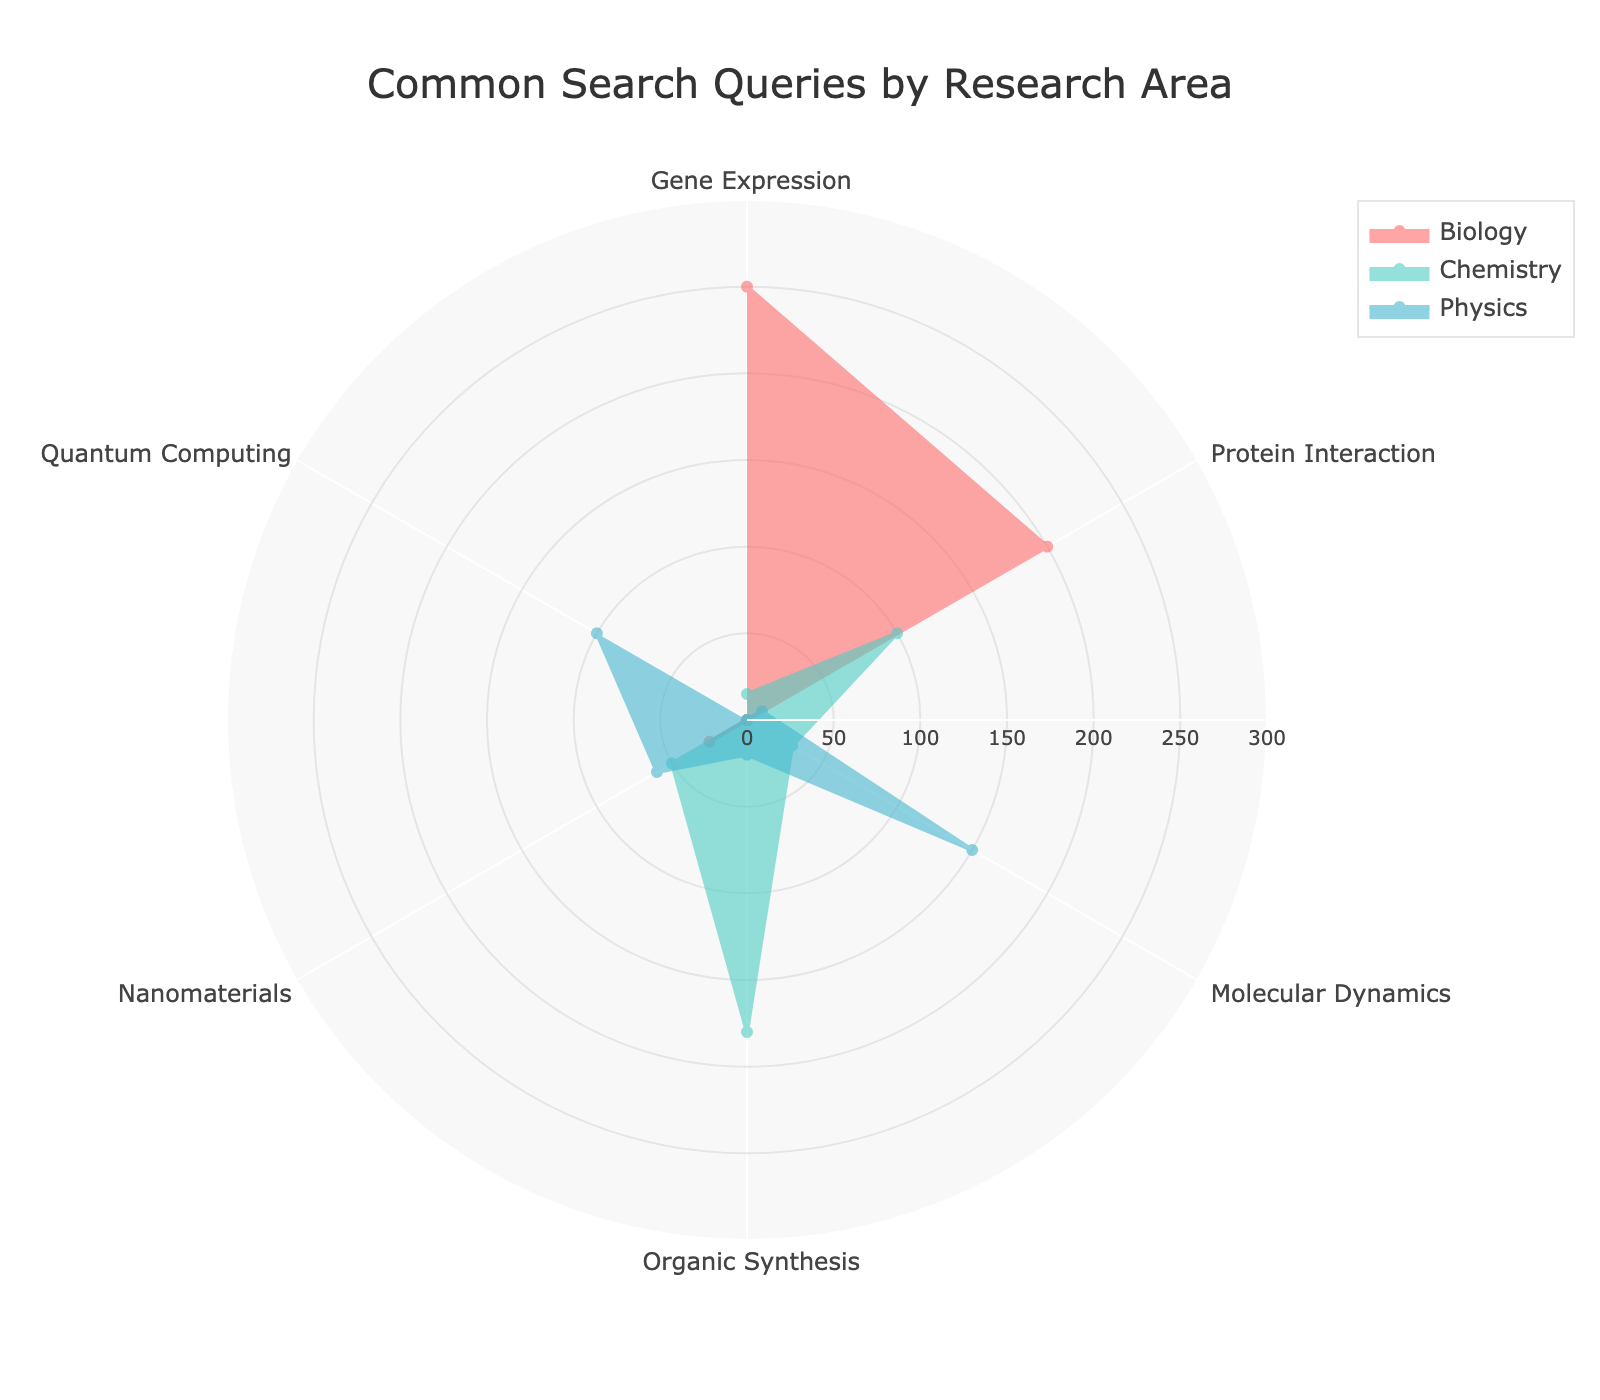What is the title of the radar chart? The title of the radar chart is displayed at the top of the figure in a large font. It indicates what the chart is about.
Answer: Common Search Queries by Research Area Which research area has the highest interest in gene expression? To determine this, look for the group with the highest value along the 'Gene Expression' axis.
Answer: Biology Compare the interest in protein interaction between Biology and Chemistry. Which one is higher? Locate the values for both Biology and Chemistry along the 'Protein Interaction' axis and compare them. Biology has 200 and Chemistry has 100. Biology's value is higher.
Answer: Biology What is the total interest in Molecular Dynamics across all research areas? Add the values of Molecular Dynamics for all research areas: Biology (0) + Chemistry (30) + Physics (150) = 180.
Answer: 180 Is there any research area that has no interest in Quantum Computing? If yes, which one? Check the values along the 'Quantum Computing' axis to see if any research area has a value of 0. Both Biology and Chemistry have a value of 0.
Answer: Biology, Chemistry How does the interest in Nanomaterials vary across the three research areas? Check the values along the 'Nanomaterials' axis for all three areas. Biology is 25, Chemistry is 50, and Physics is 60. They increase in the order of Biology < Chemistry < Physics.
Answer: Biology: 25, Chemistry: 50, Physics: 60 What is the average interest in Organic Synthesis when combining all the research areas? Calculate the average by summing the values of Organic Synthesis for all areas and dividing by the number of areas: (Biology 0 + Chemistry 180 + Physics 20) / 3 = 200 / 3 ≈ 66.67.
Answer: 66.67 Which category is exclusively of interest to Physics and not to Biology or Chemistry? Look for a value where Physics has a non-zero value and both Biology and Chemistry have zero values. Quantum Computing fits this criterion.
Answer: Quantum Computing Between Biology and Chemistry, which research area shows a higher interest in Organic Synthesis, and by how much? Compare the values for Organic Synthesis in Biology (0) and Chemistry (180). Chemistry shows a higher interest by 180 - 0 = 180.
Answer: Chemistry by 180 In which categories does Biology have zero interest? Identify the axes where Biology has a value of 0. These are Molecular Dynamics, Organic Synthesis, and Quantum Computing.
Answer: Molecular Dynamics, Organic Synthesis, Quantum Computing 